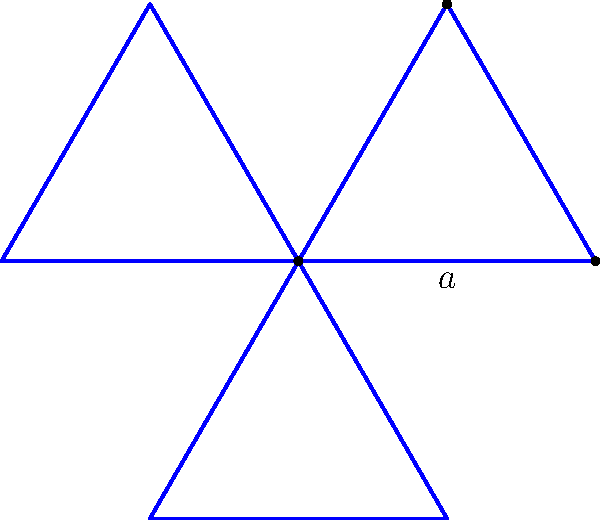Hey Bruno, remember that star-shaped logo we designed for our old company? I've been thinking about it lately. If each side of the star measures $a$ units, what's the perimeter of the entire logo? Let's approach this step-by-step:

1) First, we need to recognize that the star is composed of three identical equilateral triangles, rotated 120° from each other.

2) Each triangle has 3 sides, and each side measures $a$ units.

3) To find the perimeter, we need to count how many sides of length $a$ are in the entire star:
   - There are 3 triangles
   - Each triangle contributes 3 sides
   - So, the total number of sides is $3 \times 3 = 9$

4) Since each side has length $a$, the perimeter is the sum of all these sides:
   
   Perimeter $= 9 \times a$

5) Therefore, the perimeter of the star-shaped logo is $9a$ units.
Answer: $9a$ units 